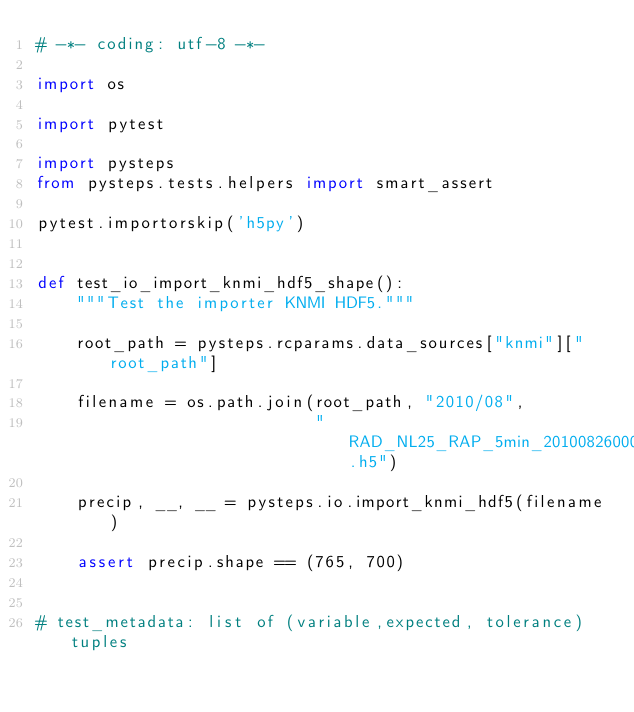<code> <loc_0><loc_0><loc_500><loc_500><_Python_># -*- coding: utf-8 -*-

import os

import pytest

import pysteps
from pysteps.tests.helpers import smart_assert

pytest.importorskip('h5py')


def test_io_import_knmi_hdf5_shape():
    """Test the importer KNMI HDF5."""

    root_path = pysteps.rcparams.data_sources["knmi"]["root_path"]

    filename = os.path.join(root_path, "2010/08",
                            "RAD_NL25_RAP_5min_201008260000.h5")

    precip, __, __ = pysteps.io.import_knmi_hdf5(filename)

    assert precip.shape == (765, 700)


# test_metadata: list of (variable,expected, tolerance) tuples
</code> 